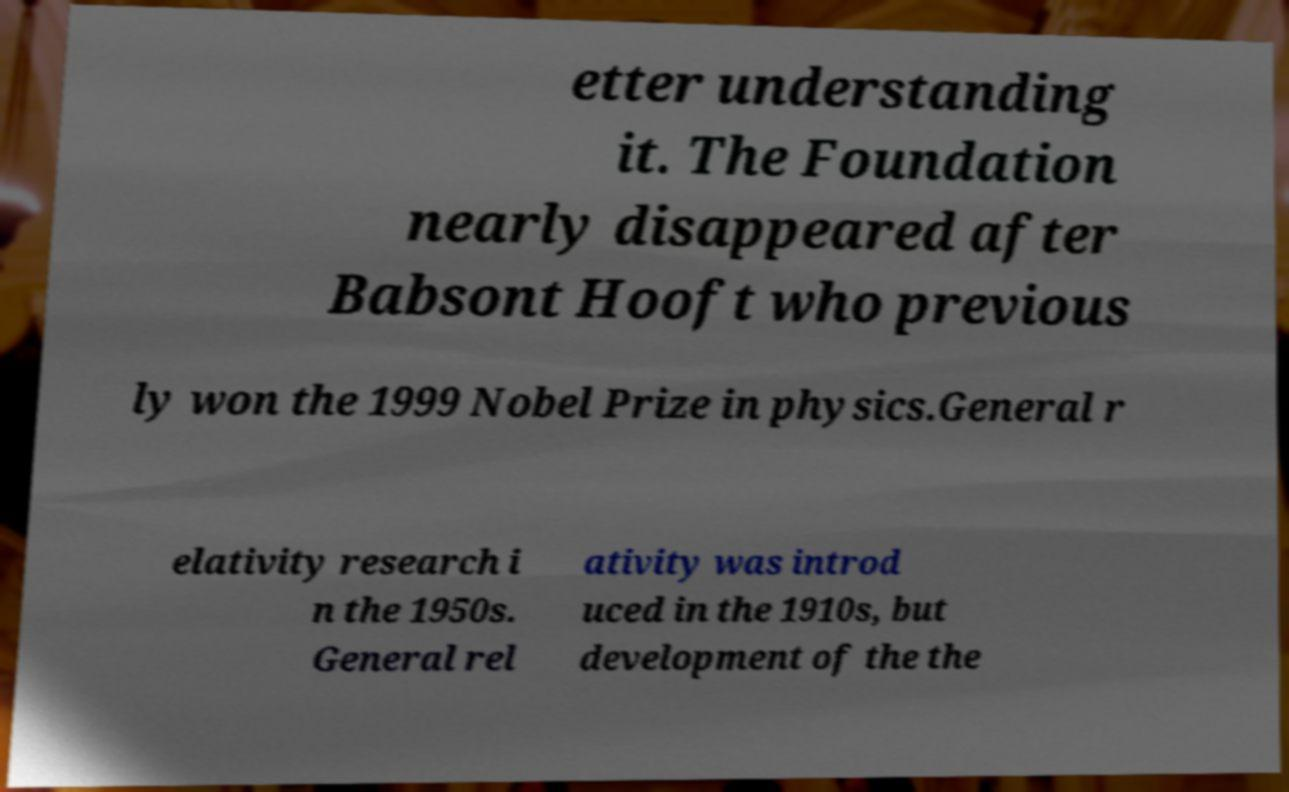For documentation purposes, I need the text within this image transcribed. Could you provide that? etter understanding it. The Foundation nearly disappeared after Babsont Hooft who previous ly won the 1999 Nobel Prize in physics.General r elativity research i n the 1950s. General rel ativity was introd uced in the 1910s, but development of the the 